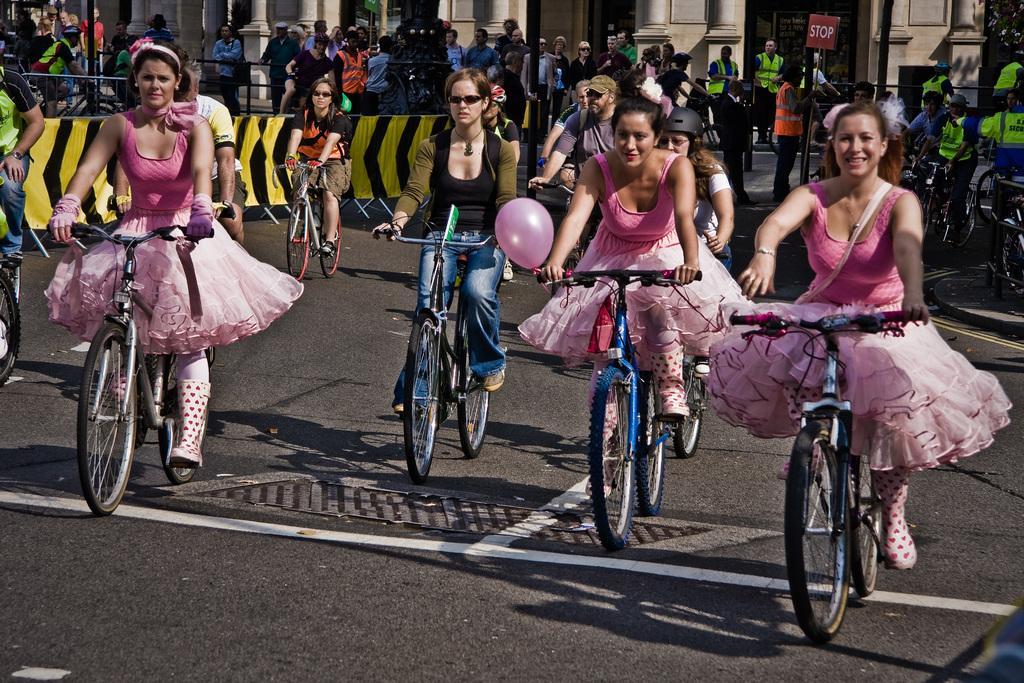Describe this image in one or two sentences. In the center we can see few group of persons were riding the bicycle. In the front we can see three women were wearing pink frocks. In the background there is a building,sign board,pole,vehicles,tree,wall and group of persons were standing. 